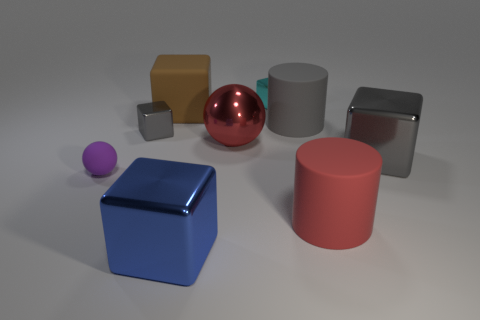Is the cube that is behind the brown object made of the same material as the gray cylinder?
Your answer should be compact. No. There is a big blue cube; are there any gray shiny cubes behind it?
Ensure brevity in your answer.  Yes. What color is the object that is to the right of the large cylinder in front of the gray shiny thing that is right of the gray matte object?
Your answer should be compact. Gray. There is a blue thing that is the same size as the brown rubber block; what shape is it?
Offer a very short reply. Cube. Is the number of large cyan matte cubes greater than the number of big blue metal blocks?
Provide a succinct answer. No. There is a big gray thing behind the tiny gray block; are there any large things behind it?
Provide a succinct answer. Yes. There is another big shiny object that is the same shape as the big blue metal object; what is its color?
Offer a very short reply. Gray. Is there anything else that is the same shape as the red rubber thing?
Provide a succinct answer. Yes. There is a small ball that is made of the same material as the large red cylinder; what is its color?
Offer a terse response. Purple. Are there any metallic blocks left of the big gray thing on the right side of the big cylinder right of the big gray cylinder?
Provide a short and direct response. Yes. 